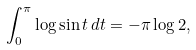<formula> <loc_0><loc_0><loc_500><loc_500>\int _ { 0 } ^ { \pi } \log \sin t \, d t = - \pi \log 2 ,</formula> 